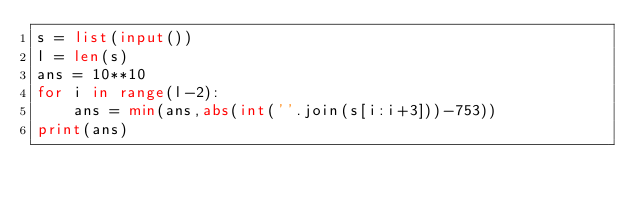<code> <loc_0><loc_0><loc_500><loc_500><_Python_>s = list(input())
l = len(s)
ans = 10**10
for i in range(l-2):
    ans = min(ans,abs(int(''.join(s[i:i+3]))-753))
print(ans)</code> 